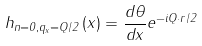Convert formula to latex. <formula><loc_0><loc_0><loc_500><loc_500>h _ { n = 0 , q _ { x } = Q / 2 } \left ( x \right ) = { \frac { d \theta } { d x } } e ^ { - i { Q } \cdot { r } / 2 }</formula> 